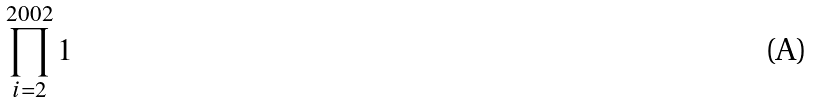<formula> <loc_0><loc_0><loc_500><loc_500>\prod _ { i = 2 } ^ { 2 0 0 2 } 1</formula> 